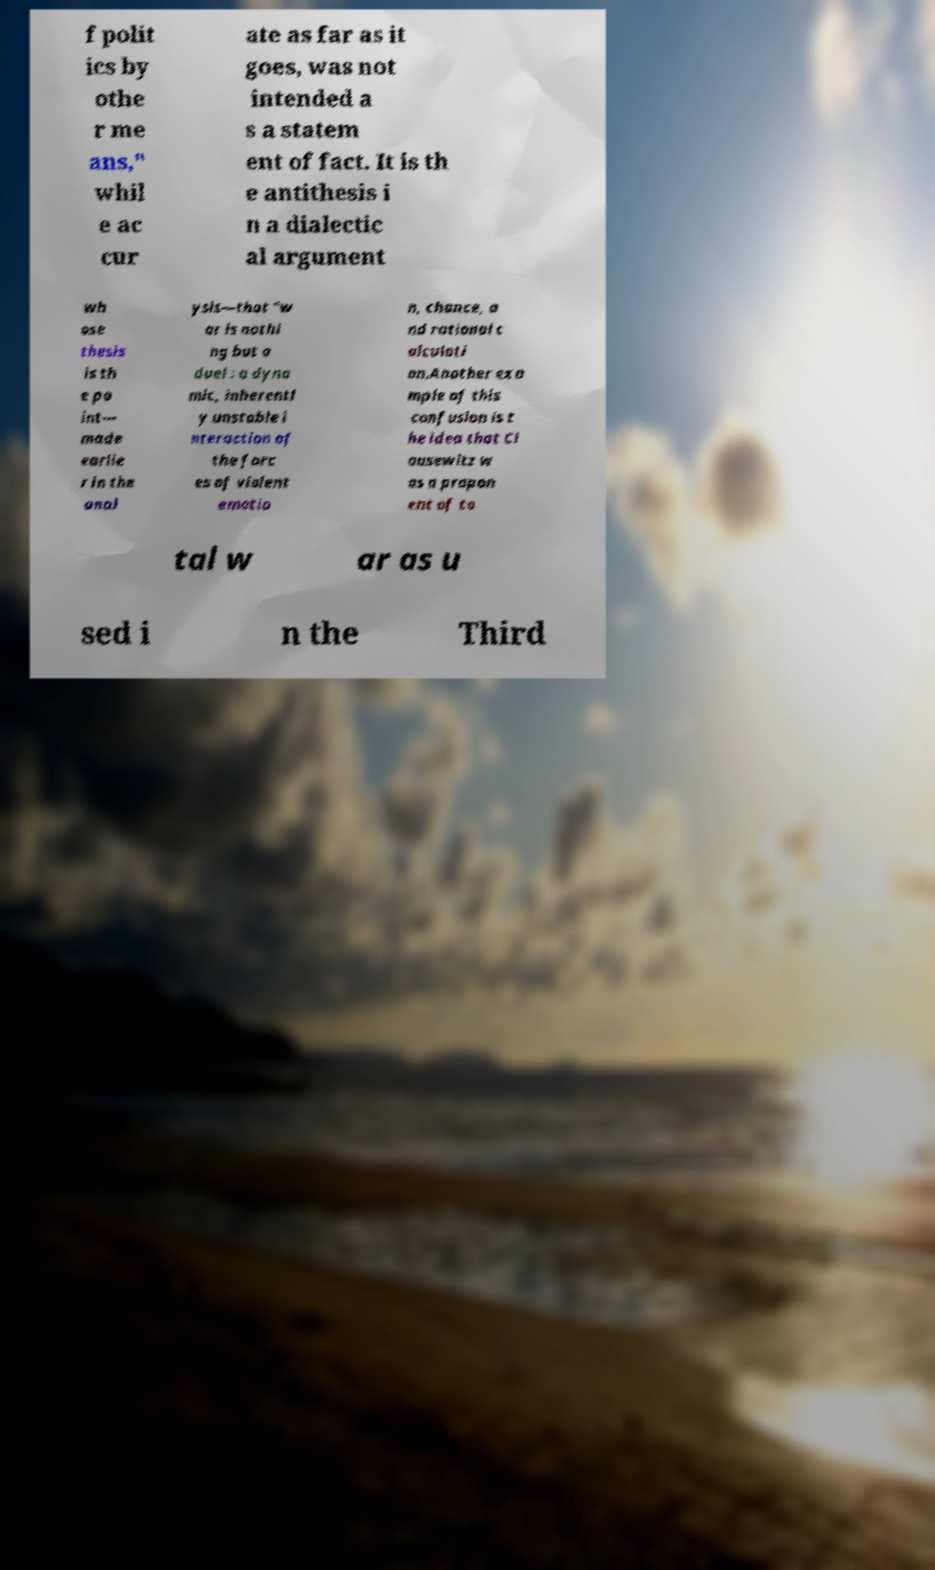There's text embedded in this image that I need extracted. Can you transcribe it verbatim? f polit ics by othe r me ans," whil e ac cur ate as far as it goes, was not intended a s a statem ent of fact. It is th e antithesis i n a dialectic al argument wh ose thesis is th e po int— made earlie r in the anal ysis—that "w ar is nothi ng but a duel : a dyna mic, inherentl y unstable i nteraction of the forc es of violent emotio n, chance, a nd rational c alculati on.Another exa mple of this confusion is t he idea that Cl ausewitz w as a propon ent of to tal w ar as u sed i n the Third 